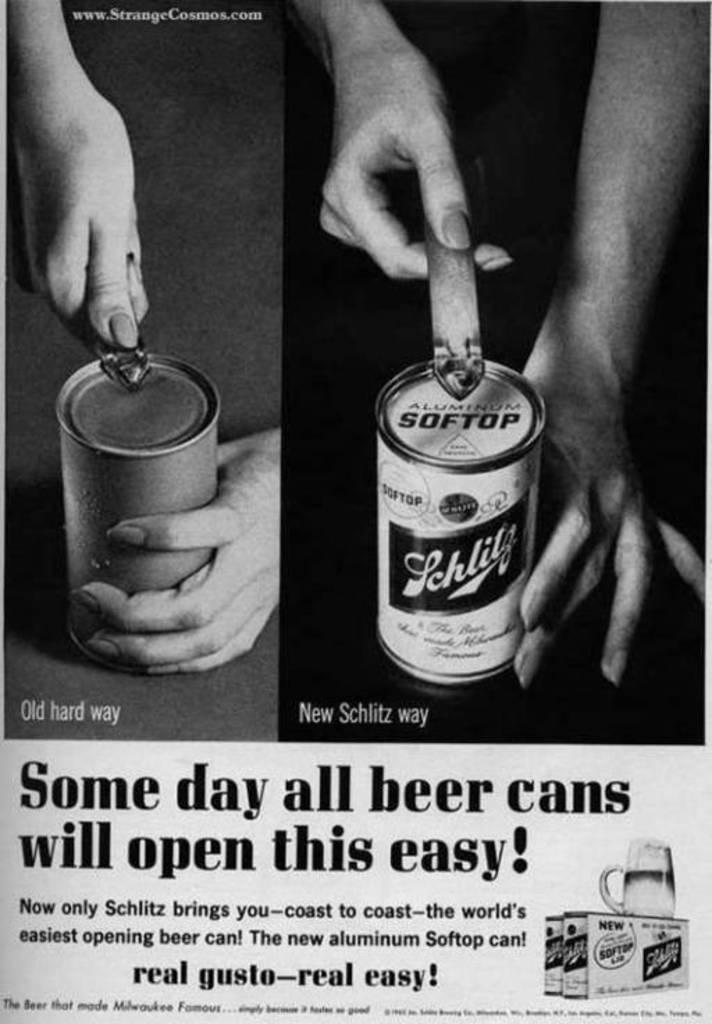Could you give a brief overview of what you see in this image? This is a poster and in this poster we can see tins, hands, glass and some text. 